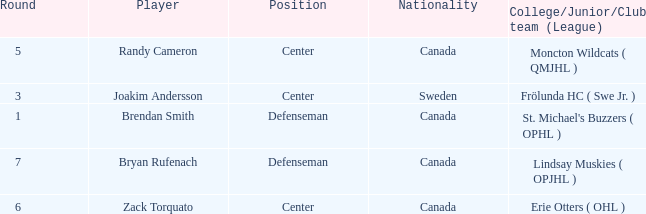Where does center Joakim Andersson come from? Sweden. 